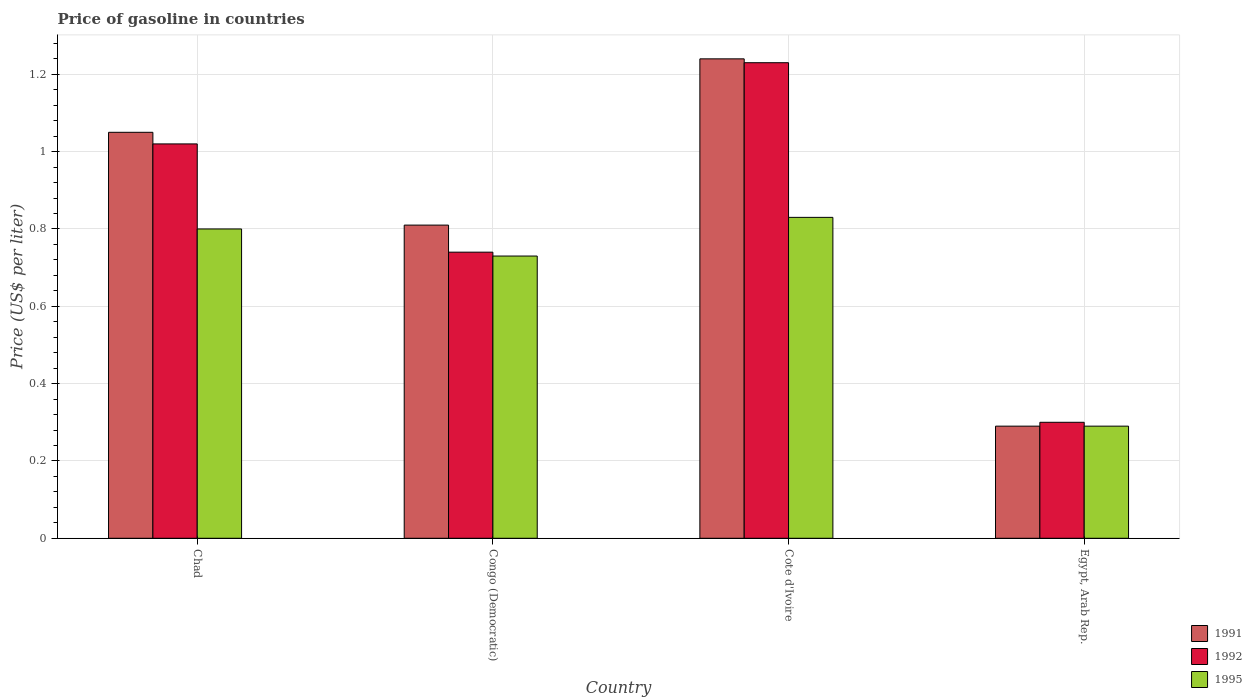How many different coloured bars are there?
Your response must be concise. 3. Are the number of bars per tick equal to the number of legend labels?
Ensure brevity in your answer.  Yes. How many bars are there on the 3rd tick from the left?
Keep it short and to the point. 3. What is the label of the 1st group of bars from the left?
Your answer should be compact. Chad. What is the price of gasoline in 1995 in Egypt, Arab Rep.?
Ensure brevity in your answer.  0.29. Across all countries, what is the maximum price of gasoline in 1992?
Your answer should be very brief. 1.23. Across all countries, what is the minimum price of gasoline in 1992?
Offer a terse response. 0.3. In which country was the price of gasoline in 1992 maximum?
Offer a terse response. Cote d'Ivoire. In which country was the price of gasoline in 1991 minimum?
Offer a very short reply. Egypt, Arab Rep. What is the total price of gasoline in 1995 in the graph?
Offer a very short reply. 2.65. What is the difference between the price of gasoline in 1991 in Chad and that in Egypt, Arab Rep.?
Your answer should be compact. 0.76. What is the difference between the price of gasoline in 1992 in Egypt, Arab Rep. and the price of gasoline in 1991 in Chad?
Your answer should be compact. -0.75. What is the average price of gasoline in 1991 per country?
Your answer should be very brief. 0.85. What is the difference between the price of gasoline of/in 1995 and price of gasoline of/in 1991 in Cote d'Ivoire?
Ensure brevity in your answer.  -0.41. What is the ratio of the price of gasoline in 1991 in Cote d'Ivoire to that in Egypt, Arab Rep.?
Provide a succinct answer. 4.28. What is the difference between the highest and the second highest price of gasoline in 1995?
Keep it short and to the point. 0.03. What is the difference between the highest and the lowest price of gasoline in 1995?
Your answer should be very brief. 0.54. In how many countries, is the price of gasoline in 1991 greater than the average price of gasoline in 1991 taken over all countries?
Provide a succinct answer. 2. Is the sum of the price of gasoline in 1991 in Congo (Democratic) and Egypt, Arab Rep. greater than the maximum price of gasoline in 1995 across all countries?
Provide a succinct answer. Yes. What does the 3rd bar from the left in Chad represents?
Make the answer very short. 1995. Is it the case that in every country, the sum of the price of gasoline in 1995 and price of gasoline in 1992 is greater than the price of gasoline in 1991?
Ensure brevity in your answer.  Yes. Are all the bars in the graph horizontal?
Your answer should be very brief. No. How many countries are there in the graph?
Your answer should be compact. 4. Are the values on the major ticks of Y-axis written in scientific E-notation?
Ensure brevity in your answer.  No. Does the graph contain grids?
Give a very brief answer. Yes. Where does the legend appear in the graph?
Keep it short and to the point. Bottom right. What is the title of the graph?
Provide a succinct answer. Price of gasoline in countries. Does "2014" appear as one of the legend labels in the graph?
Offer a terse response. No. What is the label or title of the X-axis?
Your answer should be very brief. Country. What is the label or title of the Y-axis?
Ensure brevity in your answer.  Price (US$ per liter). What is the Price (US$ per liter) of 1992 in Chad?
Your answer should be compact. 1.02. What is the Price (US$ per liter) of 1995 in Chad?
Provide a succinct answer. 0.8. What is the Price (US$ per liter) in 1991 in Congo (Democratic)?
Give a very brief answer. 0.81. What is the Price (US$ per liter) of 1992 in Congo (Democratic)?
Offer a very short reply. 0.74. What is the Price (US$ per liter) in 1995 in Congo (Democratic)?
Make the answer very short. 0.73. What is the Price (US$ per liter) of 1991 in Cote d'Ivoire?
Offer a terse response. 1.24. What is the Price (US$ per liter) in 1992 in Cote d'Ivoire?
Give a very brief answer. 1.23. What is the Price (US$ per liter) of 1995 in Cote d'Ivoire?
Your answer should be compact. 0.83. What is the Price (US$ per liter) in 1991 in Egypt, Arab Rep.?
Provide a succinct answer. 0.29. What is the Price (US$ per liter) in 1992 in Egypt, Arab Rep.?
Your answer should be compact. 0.3. What is the Price (US$ per liter) of 1995 in Egypt, Arab Rep.?
Your answer should be compact. 0.29. Across all countries, what is the maximum Price (US$ per liter) in 1991?
Your answer should be compact. 1.24. Across all countries, what is the maximum Price (US$ per liter) in 1992?
Make the answer very short. 1.23. Across all countries, what is the maximum Price (US$ per liter) of 1995?
Offer a very short reply. 0.83. Across all countries, what is the minimum Price (US$ per liter) in 1991?
Make the answer very short. 0.29. Across all countries, what is the minimum Price (US$ per liter) in 1992?
Your answer should be very brief. 0.3. Across all countries, what is the minimum Price (US$ per liter) in 1995?
Your answer should be compact. 0.29. What is the total Price (US$ per liter) of 1991 in the graph?
Make the answer very short. 3.39. What is the total Price (US$ per liter) in 1992 in the graph?
Offer a terse response. 3.29. What is the total Price (US$ per liter) of 1995 in the graph?
Offer a terse response. 2.65. What is the difference between the Price (US$ per liter) of 1991 in Chad and that in Congo (Democratic)?
Your response must be concise. 0.24. What is the difference between the Price (US$ per liter) of 1992 in Chad and that in Congo (Democratic)?
Your response must be concise. 0.28. What is the difference between the Price (US$ per liter) of 1995 in Chad and that in Congo (Democratic)?
Keep it short and to the point. 0.07. What is the difference between the Price (US$ per liter) of 1991 in Chad and that in Cote d'Ivoire?
Make the answer very short. -0.19. What is the difference between the Price (US$ per liter) of 1992 in Chad and that in Cote d'Ivoire?
Give a very brief answer. -0.21. What is the difference between the Price (US$ per liter) of 1995 in Chad and that in Cote d'Ivoire?
Provide a short and direct response. -0.03. What is the difference between the Price (US$ per liter) of 1991 in Chad and that in Egypt, Arab Rep.?
Provide a succinct answer. 0.76. What is the difference between the Price (US$ per liter) of 1992 in Chad and that in Egypt, Arab Rep.?
Your answer should be compact. 0.72. What is the difference between the Price (US$ per liter) in 1995 in Chad and that in Egypt, Arab Rep.?
Your answer should be very brief. 0.51. What is the difference between the Price (US$ per liter) in 1991 in Congo (Democratic) and that in Cote d'Ivoire?
Provide a succinct answer. -0.43. What is the difference between the Price (US$ per liter) of 1992 in Congo (Democratic) and that in Cote d'Ivoire?
Give a very brief answer. -0.49. What is the difference between the Price (US$ per liter) in 1991 in Congo (Democratic) and that in Egypt, Arab Rep.?
Provide a succinct answer. 0.52. What is the difference between the Price (US$ per liter) in 1992 in Congo (Democratic) and that in Egypt, Arab Rep.?
Your answer should be very brief. 0.44. What is the difference between the Price (US$ per liter) in 1995 in Congo (Democratic) and that in Egypt, Arab Rep.?
Your answer should be compact. 0.44. What is the difference between the Price (US$ per liter) in 1992 in Cote d'Ivoire and that in Egypt, Arab Rep.?
Offer a terse response. 0.93. What is the difference between the Price (US$ per liter) of 1995 in Cote d'Ivoire and that in Egypt, Arab Rep.?
Your answer should be compact. 0.54. What is the difference between the Price (US$ per liter) of 1991 in Chad and the Price (US$ per liter) of 1992 in Congo (Democratic)?
Your response must be concise. 0.31. What is the difference between the Price (US$ per liter) of 1991 in Chad and the Price (US$ per liter) of 1995 in Congo (Democratic)?
Your response must be concise. 0.32. What is the difference between the Price (US$ per liter) of 1992 in Chad and the Price (US$ per liter) of 1995 in Congo (Democratic)?
Your answer should be compact. 0.29. What is the difference between the Price (US$ per liter) of 1991 in Chad and the Price (US$ per liter) of 1992 in Cote d'Ivoire?
Your response must be concise. -0.18. What is the difference between the Price (US$ per liter) in 1991 in Chad and the Price (US$ per liter) in 1995 in Cote d'Ivoire?
Offer a terse response. 0.22. What is the difference between the Price (US$ per liter) of 1992 in Chad and the Price (US$ per liter) of 1995 in Cote d'Ivoire?
Provide a short and direct response. 0.19. What is the difference between the Price (US$ per liter) of 1991 in Chad and the Price (US$ per liter) of 1992 in Egypt, Arab Rep.?
Provide a short and direct response. 0.75. What is the difference between the Price (US$ per liter) in 1991 in Chad and the Price (US$ per liter) in 1995 in Egypt, Arab Rep.?
Provide a short and direct response. 0.76. What is the difference between the Price (US$ per liter) of 1992 in Chad and the Price (US$ per liter) of 1995 in Egypt, Arab Rep.?
Your answer should be very brief. 0.73. What is the difference between the Price (US$ per liter) of 1991 in Congo (Democratic) and the Price (US$ per liter) of 1992 in Cote d'Ivoire?
Provide a short and direct response. -0.42. What is the difference between the Price (US$ per liter) of 1991 in Congo (Democratic) and the Price (US$ per liter) of 1995 in Cote d'Ivoire?
Give a very brief answer. -0.02. What is the difference between the Price (US$ per liter) in 1992 in Congo (Democratic) and the Price (US$ per liter) in 1995 in Cote d'Ivoire?
Provide a short and direct response. -0.09. What is the difference between the Price (US$ per liter) of 1991 in Congo (Democratic) and the Price (US$ per liter) of 1992 in Egypt, Arab Rep.?
Keep it short and to the point. 0.51. What is the difference between the Price (US$ per liter) of 1991 in Congo (Democratic) and the Price (US$ per liter) of 1995 in Egypt, Arab Rep.?
Your answer should be compact. 0.52. What is the difference between the Price (US$ per liter) of 1992 in Congo (Democratic) and the Price (US$ per liter) of 1995 in Egypt, Arab Rep.?
Provide a succinct answer. 0.45. What is the difference between the Price (US$ per liter) in 1991 in Cote d'Ivoire and the Price (US$ per liter) in 1995 in Egypt, Arab Rep.?
Your answer should be very brief. 0.95. What is the difference between the Price (US$ per liter) of 1992 in Cote d'Ivoire and the Price (US$ per liter) of 1995 in Egypt, Arab Rep.?
Your answer should be very brief. 0.94. What is the average Price (US$ per liter) in 1991 per country?
Provide a succinct answer. 0.85. What is the average Price (US$ per liter) of 1992 per country?
Ensure brevity in your answer.  0.82. What is the average Price (US$ per liter) of 1995 per country?
Keep it short and to the point. 0.66. What is the difference between the Price (US$ per liter) in 1991 and Price (US$ per liter) in 1992 in Chad?
Offer a very short reply. 0.03. What is the difference between the Price (US$ per liter) of 1992 and Price (US$ per liter) of 1995 in Chad?
Your answer should be compact. 0.22. What is the difference between the Price (US$ per liter) in 1991 and Price (US$ per liter) in 1992 in Congo (Democratic)?
Your response must be concise. 0.07. What is the difference between the Price (US$ per liter) in 1992 and Price (US$ per liter) in 1995 in Congo (Democratic)?
Your response must be concise. 0.01. What is the difference between the Price (US$ per liter) in 1991 and Price (US$ per liter) in 1995 in Cote d'Ivoire?
Provide a short and direct response. 0.41. What is the difference between the Price (US$ per liter) in 1992 and Price (US$ per liter) in 1995 in Cote d'Ivoire?
Your answer should be very brief. 0.4. What is the difference between the Price (US$ per liter) of 1991 and Price (US$ per liter) of 1992 in Egypt, Arab Rep.?
Provide a short and direct response. -0.01. What is the difference between the Price (US$ per liter) in 1991 and Price (US$ per liter) in 1995 in Egypt, Arab Rep.?
Offer a terse response. 0. What is the difference between the Price (US$ per liter) of 1992 and Price (US$ per liter) of 1995 in Egypt, Arab Rep.?
Offer a terse response. 0.01. What is the ratio of the Price (US$ per liter) of 1991 in Chad to that in Congo (Democratic)?
Offer a very short reply. 1.3. What is the ratio of the Price (US$ per liter) of 1992 in Chad to that in Congo (Democratic)?
Offer a terse response. 1.38. What is the ratio of the Price (US$ per liter) in 1995 in Chad to that in Congo (Democratic)?
Provide a short and direct response. 1.1. What is the ratio of the Price (US$ per liter) in 1991 in Chad to that in Cote d'Ivoire?
Provide a short and direct response. 0.85. What is the ratio of the Price (US$ per liter) of 1992 in Chad to that in Cote d'Ivoire?
Keep it short and to the point. 0.83. What is the ratio of the Price (US$ per liter) in 1995 in Chad to that in Cote d'Ivoire?
Ensure brevity in your answer.  0.96. What is the ratio of the Price (US$ per liter) of 1991 in Chad to that in Egypt, Arab Rep.?
Offer a terse response. 3.62. What is the ratio of the Price (US$ per liter) in 1992 in Chad to that in Egypt, Arab Rep.?
Keep it short and to the point. 3.4. What is the ratio of the Price (US$ per liter) of 1995 in Chad to that in Egypt, Arab Rep.?
Provide a succinct answer. 2.76. What is the ratio of the Price (US$ per liter) in 1991 in Congo (Democratic) to that in Cote d'Ivoire?
Give a very brief answer. 0.65. What is the ratio of the Price (US$ per liter) in 1992 in Congo (Democratic) to that in Cote d'Ivoire?
Keep it short and to the point. 0.6. What is the ratio of the Price (US$ per liter) in 1995 in Congo (Democratic) to that in Cote d'Ivoire?
Give a very brief answer. 0.88. What is the ratio of the Price (US$ per liter) in 1991 in Congo (Democratic) to that in Egypt, Arab Rep.?
Provide a short and direct response. 2.79. What is the ratio of the Price (US$ per liter) of 1992 in Congo (Democratic) to that in Egypt, Arab Rep.?
Offer a terse response. 2.47. What is the ratio of the Price (US$ per liter) of 1995 in Congo (Democratic) to that in Egypt, Arab Rep.?
Keep it short and to the point. 2.52. What is the ratio of the Price (US$ per liter) in 1991 in Cote d'Ivoire to that in Egypt, Arab Rep.?
Your answer should be compact. 4.28. What is the ratio of the Price (US$ per liter) of 1992 in Cote d'Ivoire to that in Egypt, Arab Rep.?
Provide a succinct answer. 4.1. What is the ratio of the Price (US$ per liter) in 1995 in Cote d'Ivoire to that in Egypt, Arab Rep.?
Offer a terse response. 2.86. What is the difference between the highest and the second highest Price (US$ per liter) of 1991?
Your answer should be very brief. 0.19. What is the difference between the highest and the second highest Price (US$ per liter) in 1992?
Make the answer very short. 0.21. What is the difference between the highest and the second highest Price (US$ per liter) in 1995?
Give a very brief answer. 0.03. What is the difference between the highest and the lowest Price (US$ per liter) in 1991?
Your response must be concise. 0.95. What is the difference between the highest and the lowest Price (US$ per liter) of 1992?
Offer a terse response. 0.93. What is the difference between the highest and the lowest Price (US$ per liter) of 1995?
Your answer should be compact. 0.54. 